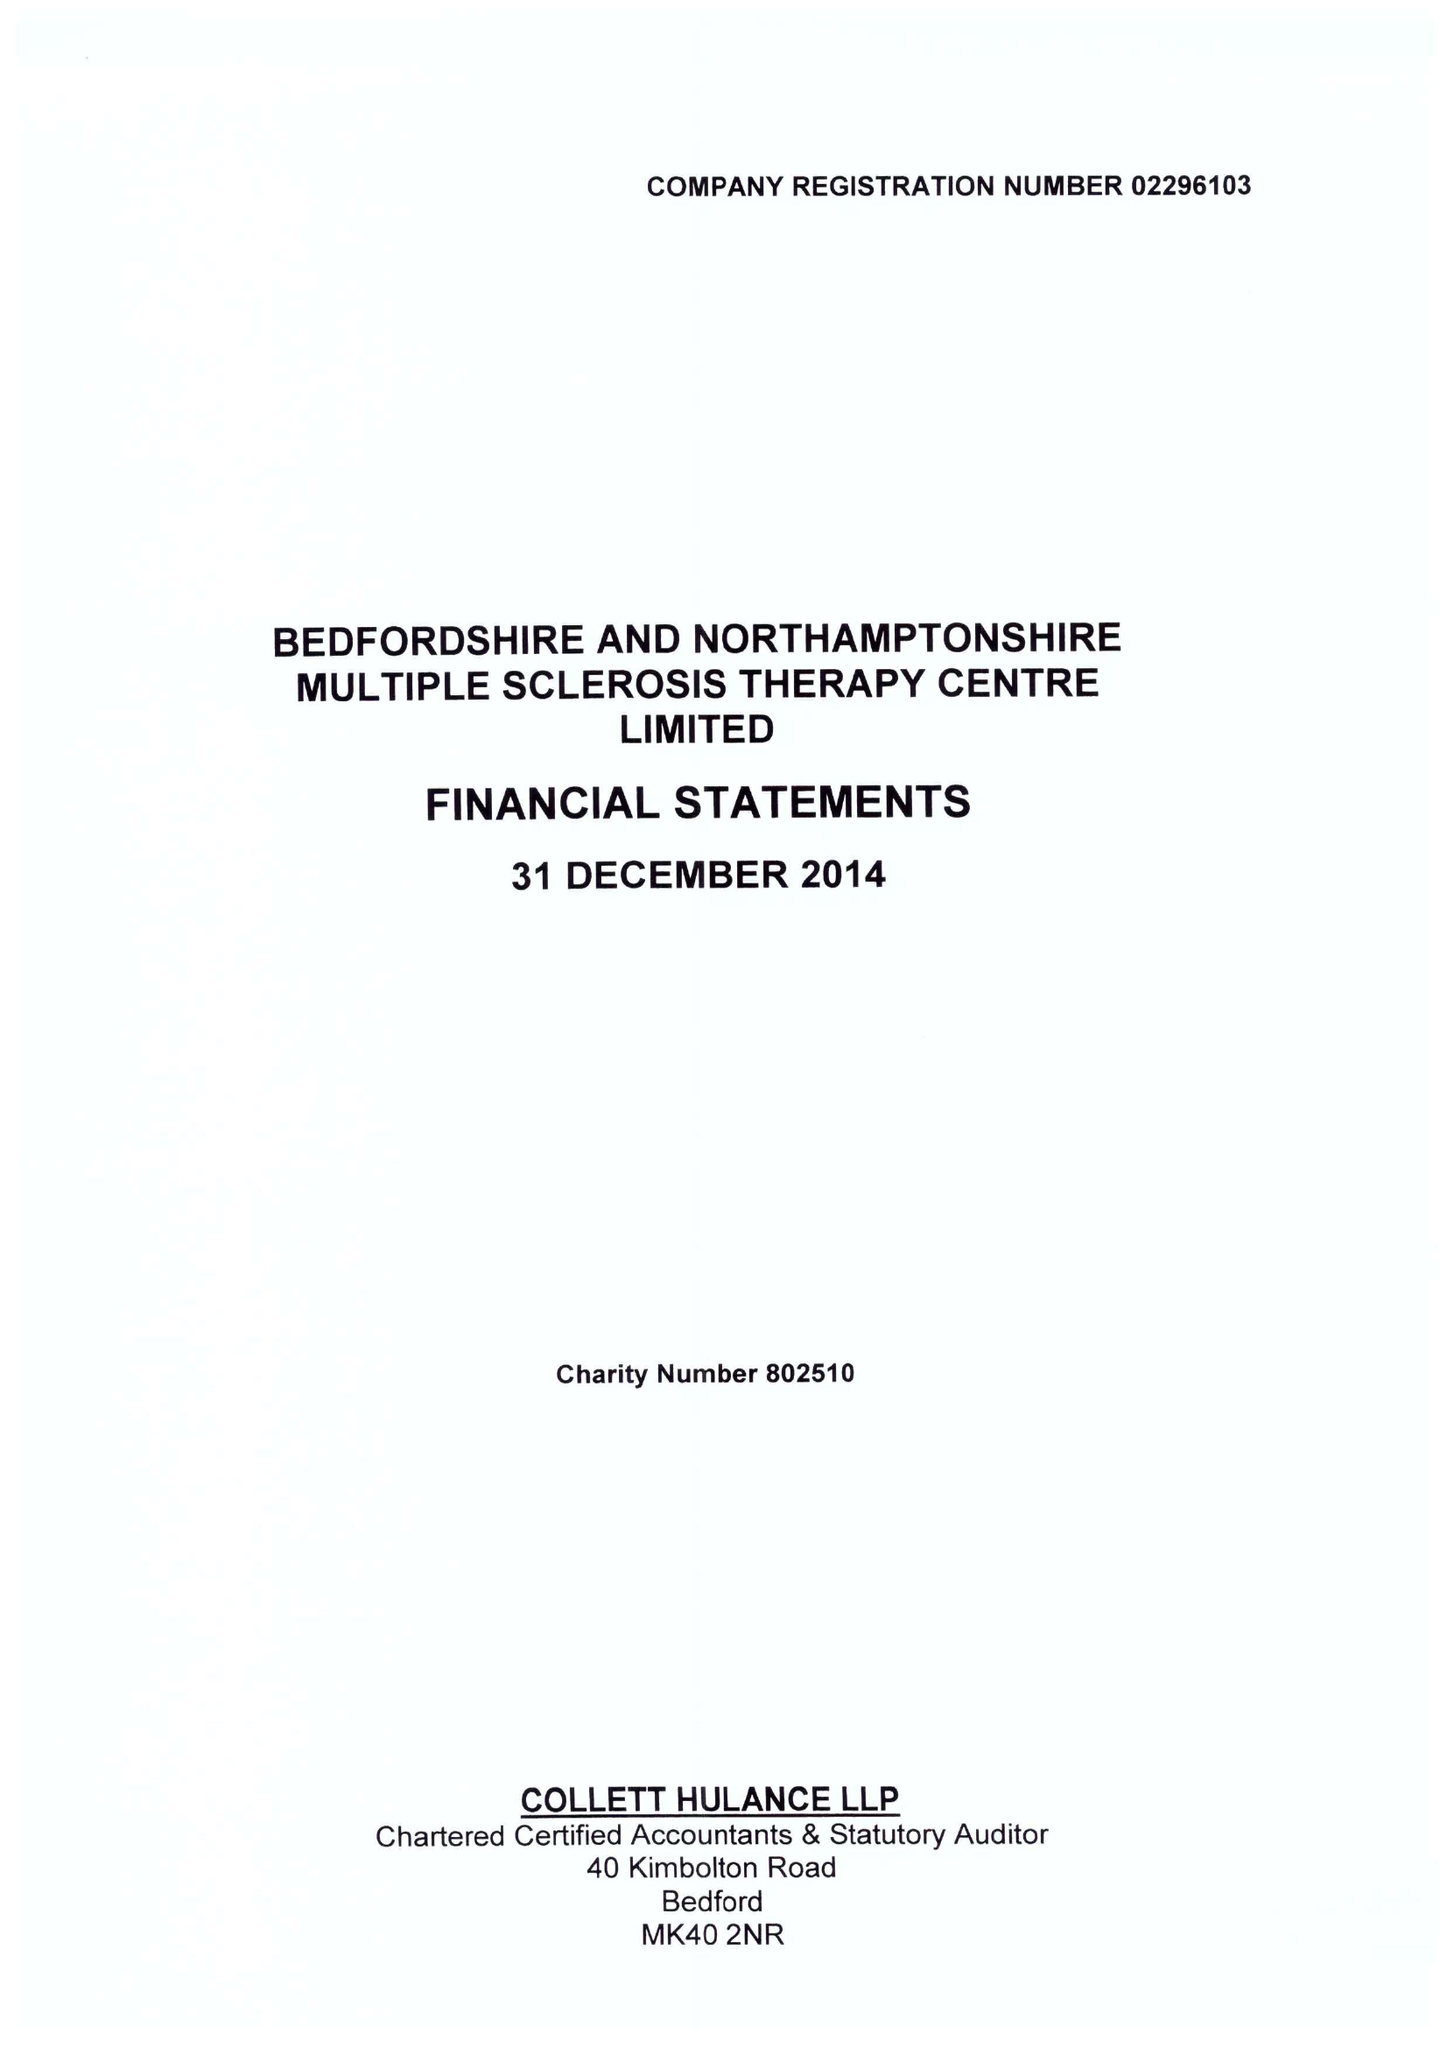What is the value for the address__postcode?
Answer the question using a single word or phrase. MK41 9RX 